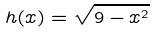Convert formula to latex. <formula><loc_0><loc_0><loc_500><loc_500>h ( x ) = \sqrt { 9 - x ^ { 2 } }</formula> 